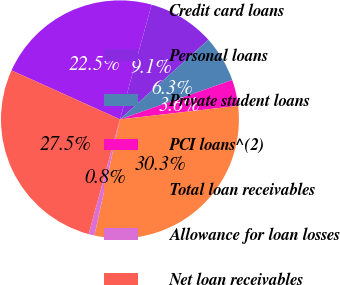Convert chart. <chart><loc_0><loc_0><loc_500><loc_500><pie_chart><fcel>Credit card loans<fcel>Personal loans<fcel>Private student loans<fcel>PCI loans^(2)<fcel>Total loan receivables<fcel>Allowance for loan losses<fcel>Net loan receivables<nl><fcel>22.54%<fcel>9.05%<fcel>6.3%<fcel>3.55%<fcel>30.26%<fcel>0.79%<fcel>27.51%<nl></chart> 